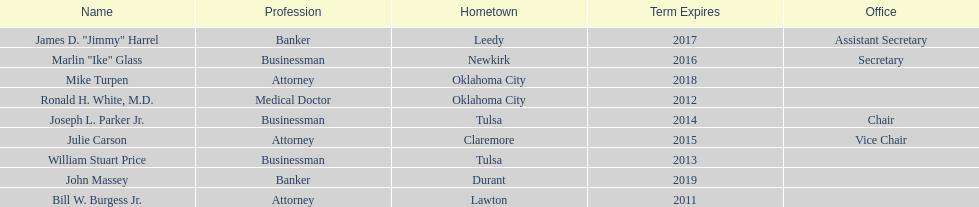How many of the current state regents will be in office until at least 2016? 4. 